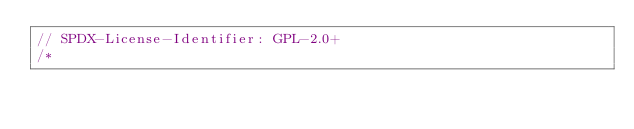<code> <loc_0><loc_0><loc_500><loc_500><_C_>// SPDX-License-Identifier: GPL-2.0+
/*</code> 